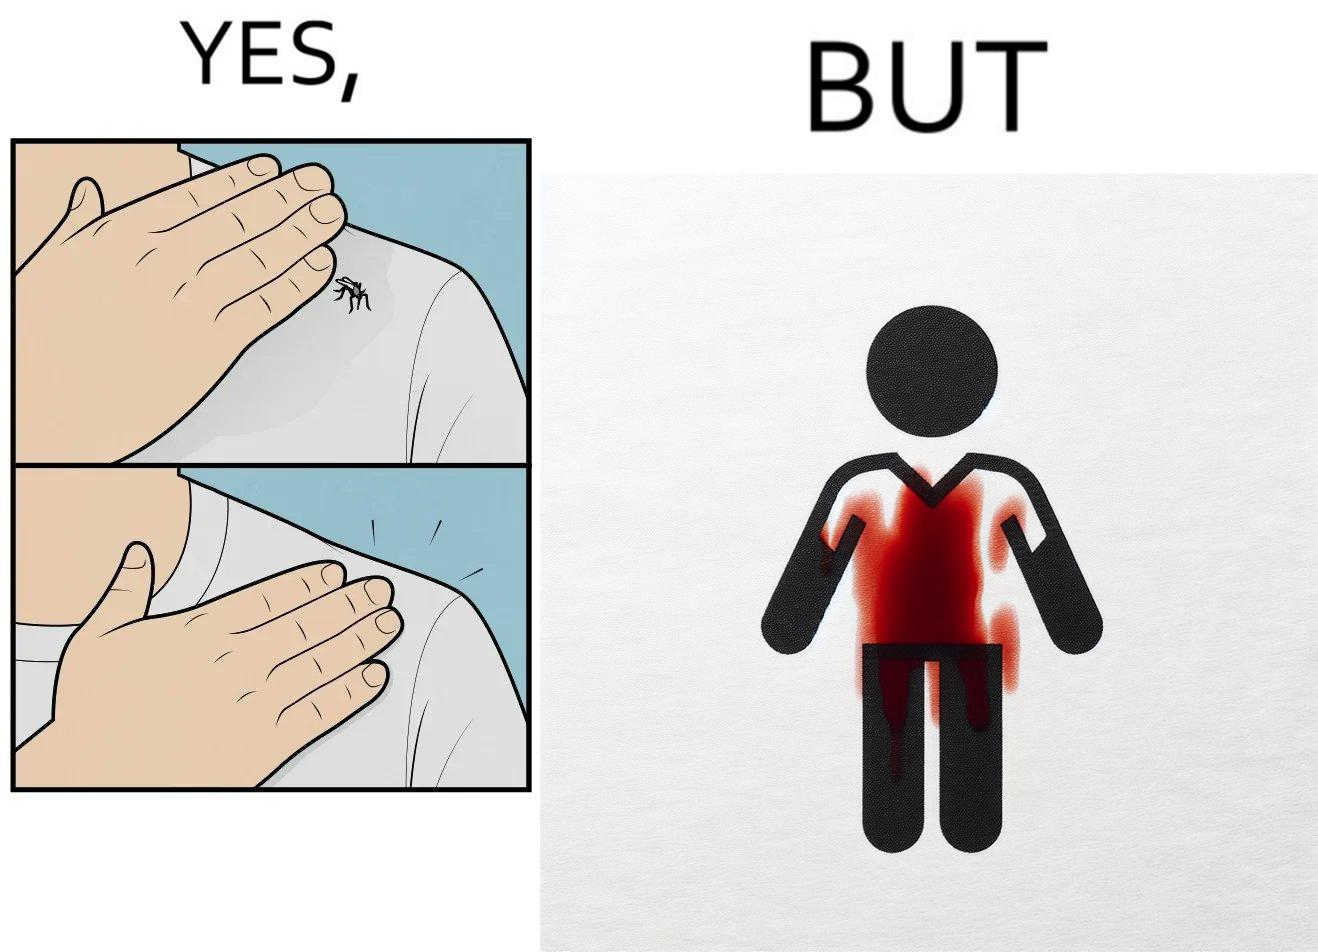Is there satirical content in this image? Yes, this image is satirical. 